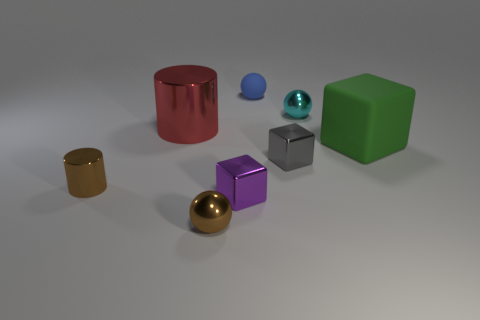Subtract all purple blocks. How many blocks are left? 2 Subtract 1 cylinders. How many cylinders are left? 1 Add 2 large matte blocks. How many objects exist? 10 Subtract all purple blocks. How many blocks are left? 2 Subtract all blocks. How many objects are left? 5 Add 1 tiny blue rubber blocks. How many tiny blue rubber blocks exist? 1 Subtract 0 cyan blocks. How many objects are left? 8 Subtract all brown cylinders. Subtract all brown balls. How many cylinders are left? 1 Subtract all cyan blocks. How many blue spheres are left? 1 Subtract all purple cylinders. Subtract all purple objects. How many objects are left? 7 